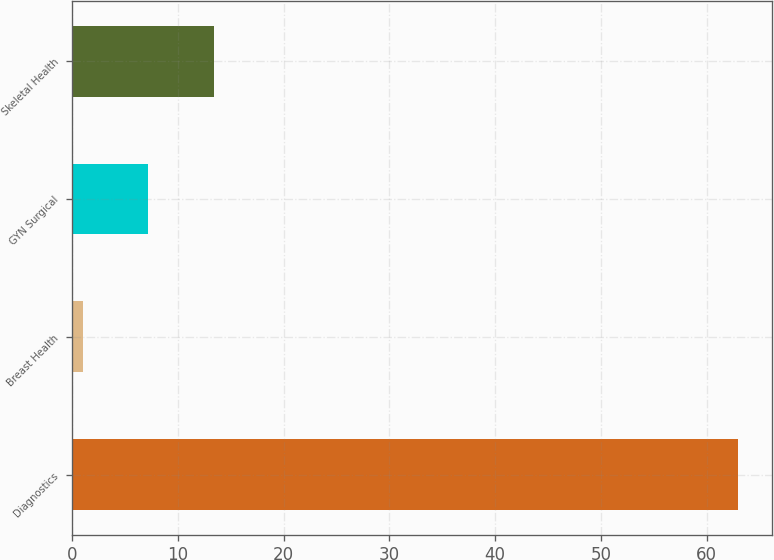Convert chart. <chart><loc_0><loc_0><loc_500><loc_500><bar_chart><fcel>Diagnostics<fcel>Breast Health<fcel>GYN Surgical<fcel>Skeletal Health<nl><fcel>63<fcel>1<fcel>7.2<fcel>13.4<nl></chart> 